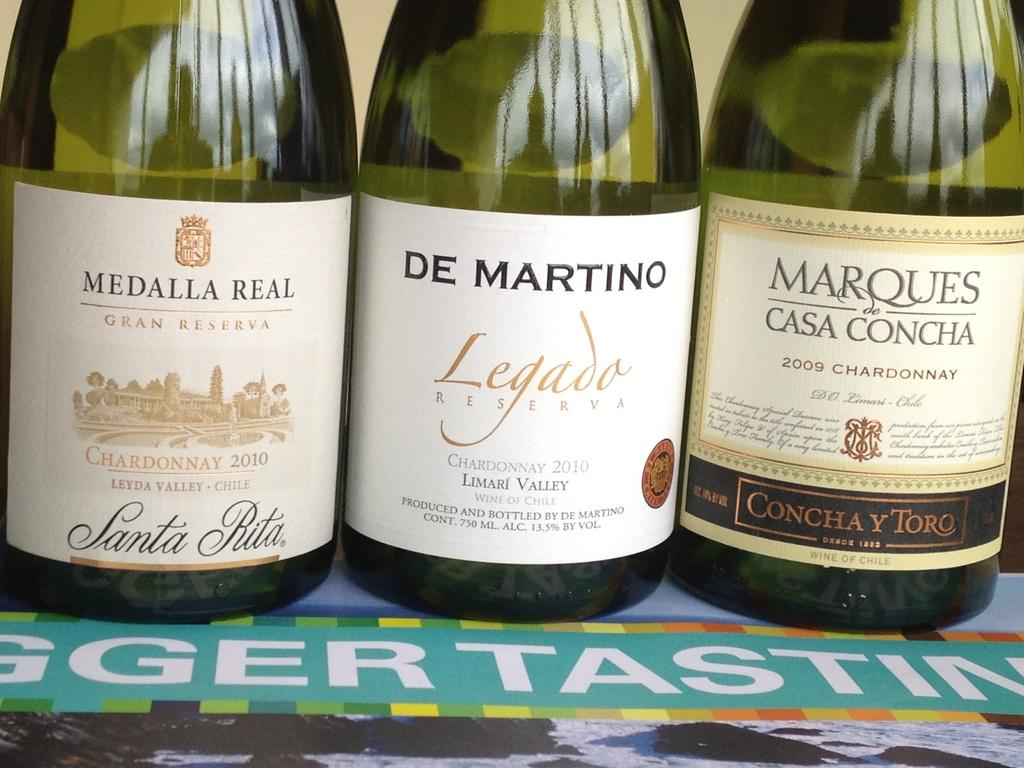<image>
Relay a brief, clear account of the picture shown. the word Ledado is on a wine bottle 